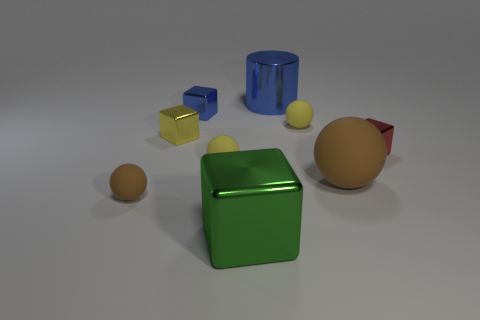What materials are the objects made of, judging by their appearance? Based on their appearance, the objects seem to be of various materials. The translucent green and blue objects have the shiny, reflective surface typical of plastic or glass. The yellow and brown spheres, as well as the large peach-colored object, have a more matte finish, suggesting they could be made of rubber or a similar non-reflective material. Can you tell which objects are reflective? The cube-shaped objects, one being blue and the other green, exhibit reflective properties, indicating a potential metallic or glassy material. Their surfaces catch the light and show highlights and reflections. 